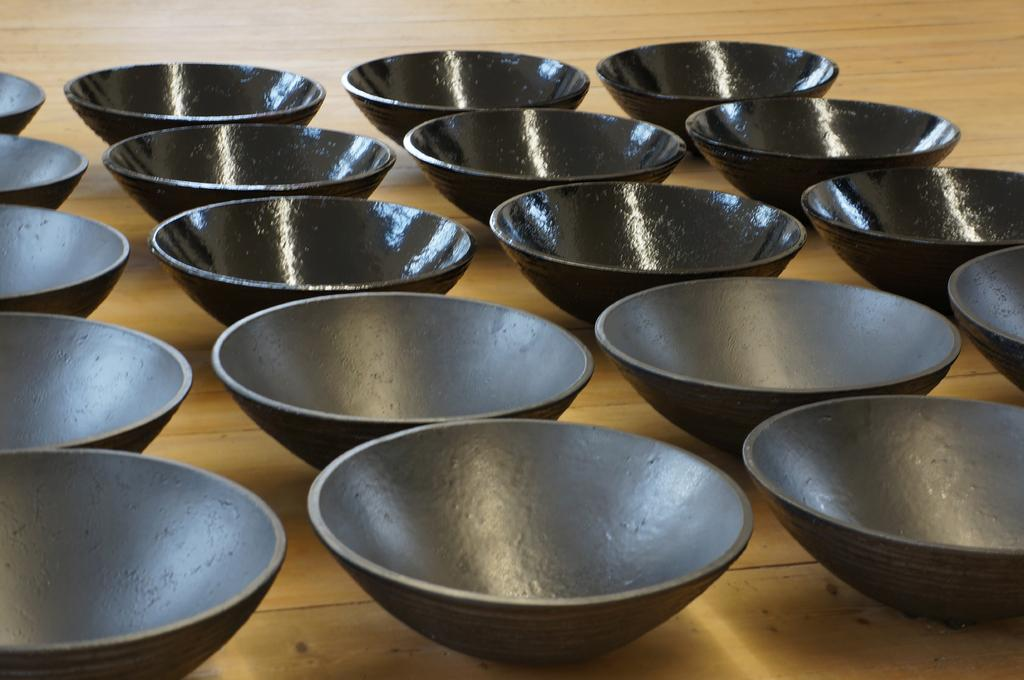What piece of furniture is present in the image? There is a table in the image. What color are the bowls on the table? The bowls on the table are black. What type of war is depicted in the image? There is no war depicted in the image; it only features a table and black bowls. 